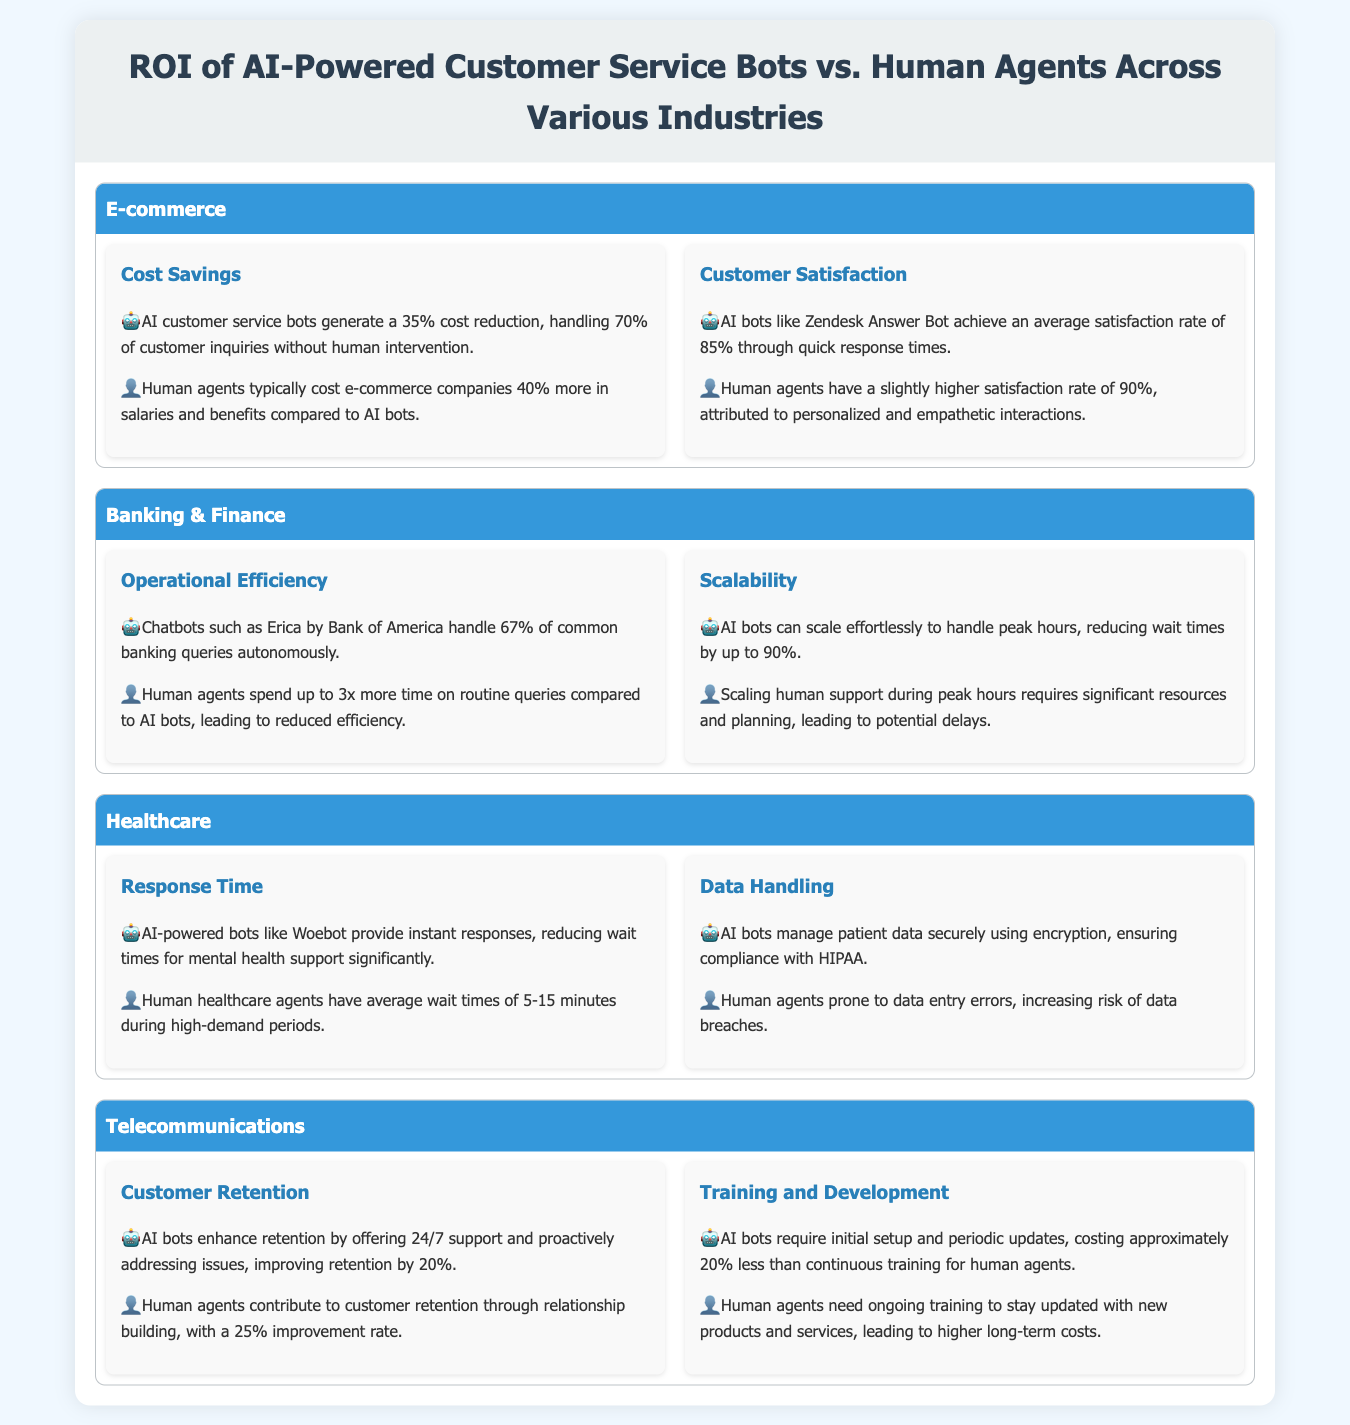what is the percentage of cost reduction generated by AI customer service bots in e-commerce? The document states that AI customer service bots generate a 35% cost reduction in e-commerce.
Answer: 35% what is the average satisfaction rate achieved by AI bots like Zendesk Answer Bot? According to the document, AI bots like Zendesk Answer Bot achieve an average satisfaction rate of 85%.
Answer: 85% how much more do human agents typically cost e-commerce companies compared to AI bots? The document mentions that human agents typically cost e-commerce companies 40% more in salaries and benefits compared to AI bots.
Answer: 40% what percentage of routine queries do AI bots handle in banking and finance? The document states that AI bots like Erica by Bank of America handle 67% of common banking queries autonomously.
Answer: 67% which industry sees a 20% improvement in customer retention due to AI bots? The document highlights that AI bots in telecommunications enhance retention by offering 24/7 support, improving retention by 20%.
Answer: Telecommunications how much longer do human agents spend on routine queries compared to AI bots in banking? The document indicates that human agents spend up to 3 times more time on routine queries compared to AI bots.
Answer: 3 times what factor contributes to the higher long-term costs of human agents? The document asserts that human agents need ongoing training to stay updated with new products, leading to higher long-term costs.
Answer: Ongoing training what is the reduction in wait times during peak hours when using AI bots? The document states that AI bots can reduce wait times by up to 90% during peak hours.
Answer: 90% how do AI bots ensure compliance with data security regulations in healthcare? The document specifies that AI bots manage patient data securely using encryption, ensuring compliance with HIPAA.
Answer: Encryption 